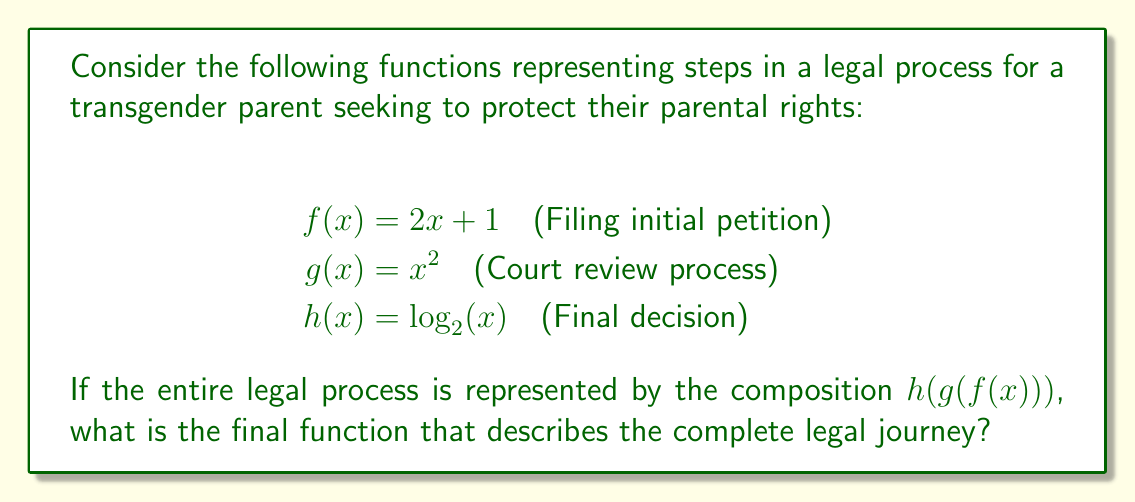Provide a solution to this math problem. To find the composition $h(g(f(x)))$, we need to work from the inside out:

1) First, we apply $f(x) = 2x + 1$

2) Then, we apply $g$ to the result of $f(x)$:
   $g(f(x)) = g(2x + 1) = (2x + 1)^2$

3) Finally, we apply $h$ to the result of $g(f(x))$:
   $h(g(f(x))) = h((2x + 1)^2) = \log_2((2x + 1)^2)$

4) Using the logarithm property $\log_a(x^n) = n\log_a(x)$, we can simplify:
   $\log_2((2x + 1)^2) = 2\log_2(2x + 1)$

Therefore, the final function that describes the complete legal journey is:

$h(g(f(x))) = 2\log_2(2x + 1)$
Answer: $2\log_2(2x + 1)$ 